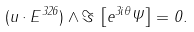<formula> <loc_0><loc_0><loc_500><loc_500>( u \cdot E ^ { 3 2 6 } ) \wedge \Im \, \left [ e ^ { 3 i \theta } \Psi \right ] = 0 .</formula> 